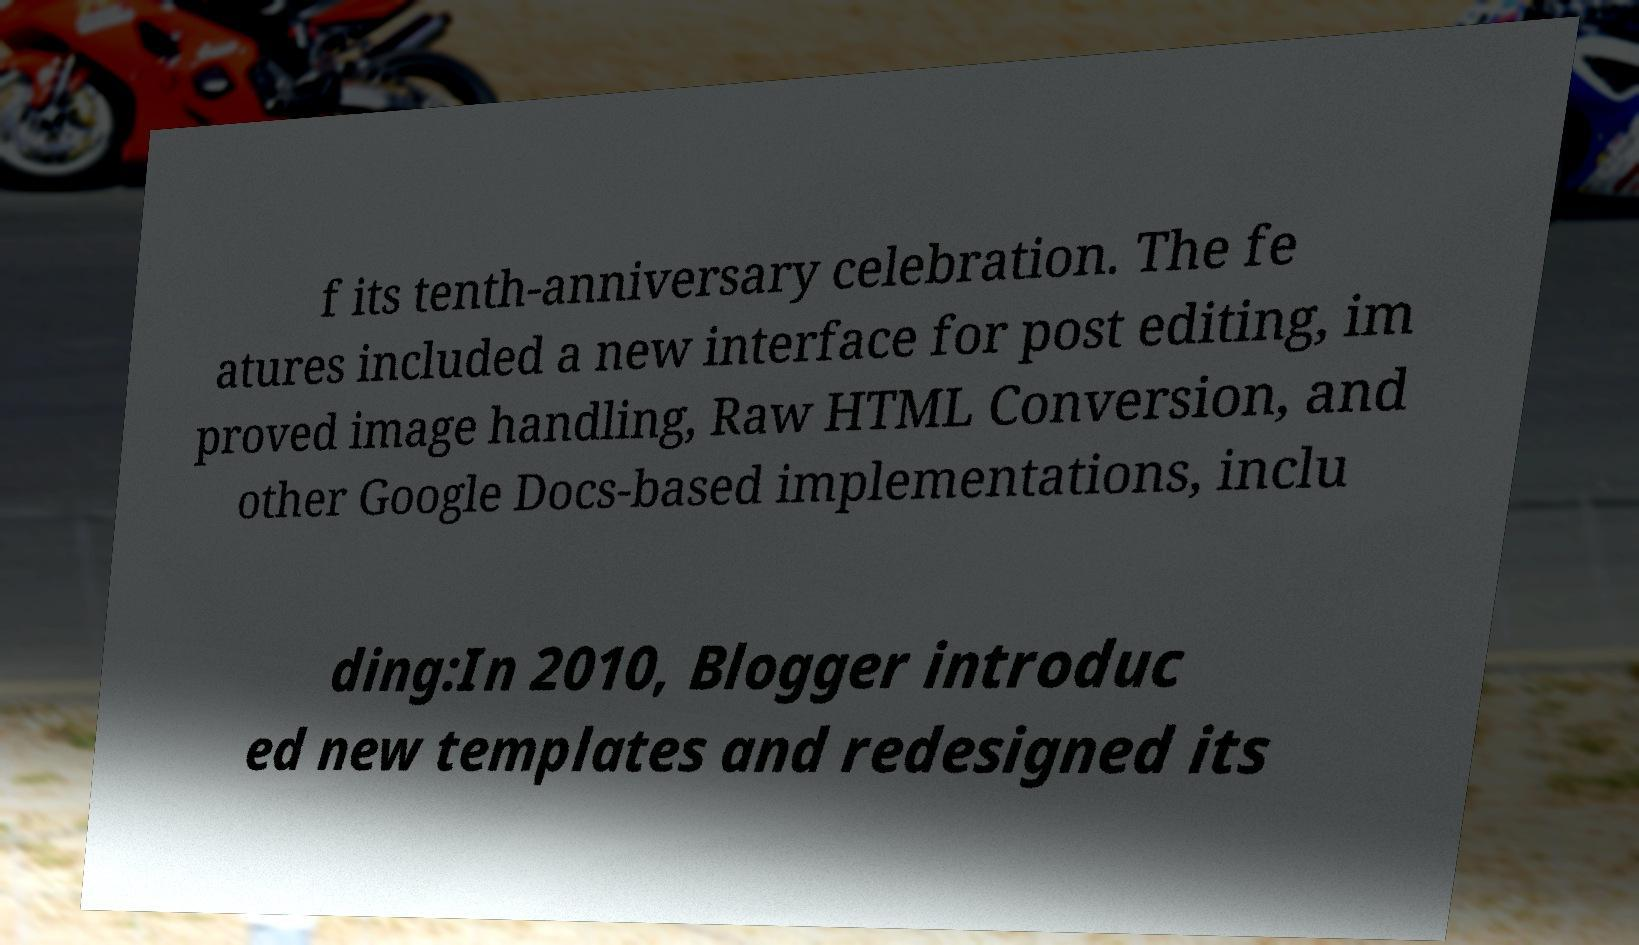Could you extract and type out the text from this image? f its tenth-anniversary celebration. The fe atures included a new interface for post editing, im proved image handling, Raw HTML Conversion, and other Google Docs-based implementations, inclu ding:In 2010, Blogger introduc ed new templates and redesigned its 